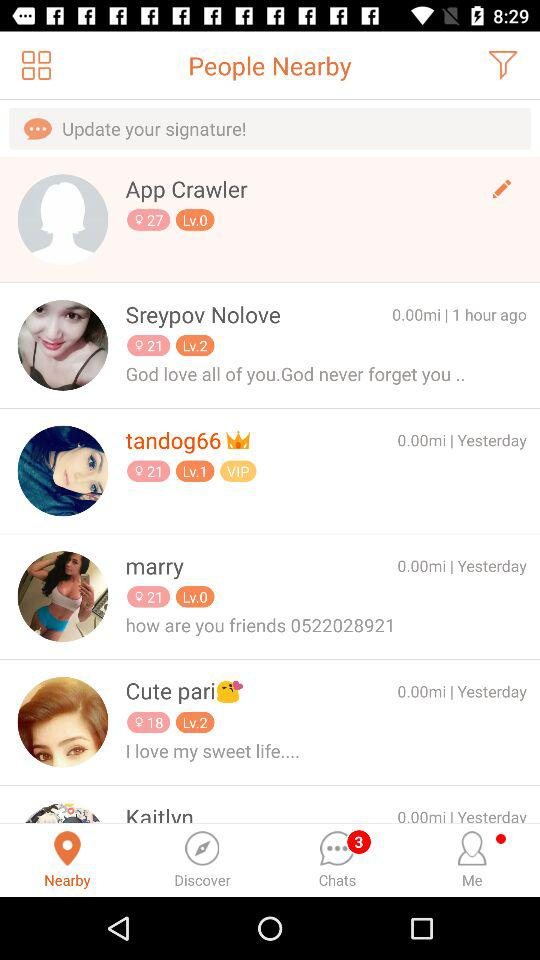Cute Pari's last post was how many days ago? Cute Pari's last post was from yesterday. 